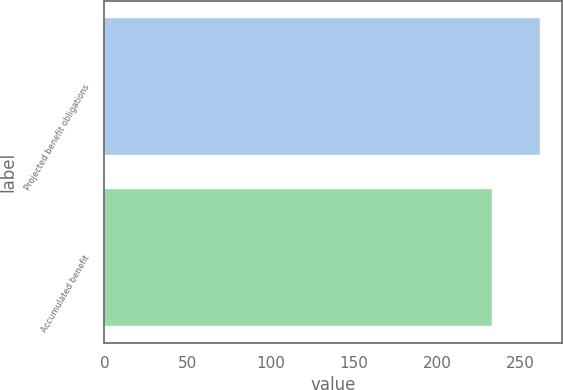Convert chart. <chart><loc_0><loc_0><loc_500><loc_500><bar_chart><fcel>Projected benefit obligations<fcel>Accumulated benefit<nl><fcel>262<fcel>233<nl></chart> 